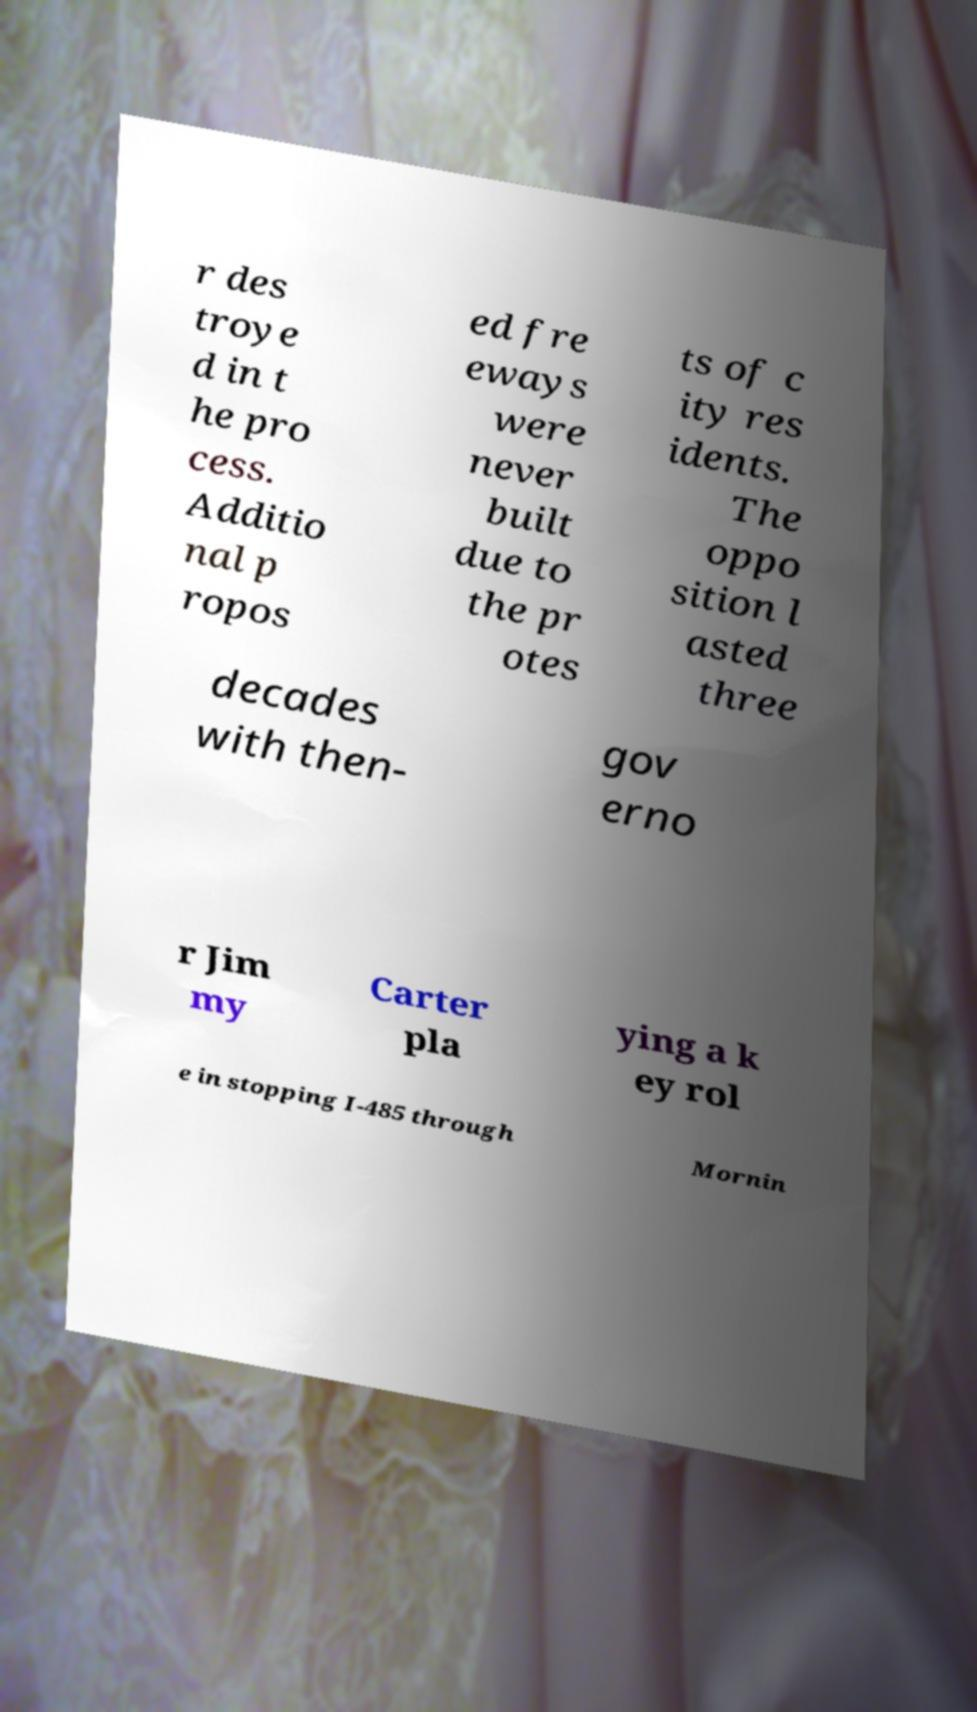I need the written content from this picture converted into text. Can you do that? r des troye d in t he pro cess. Additio nal p ropos ed fre eways were never built due to the pr otes ts of c ity res idents. The oppo sition l asted three decades with then- gov erno r Jim my Carter pla ying a k ey rol e in stopping I-485 through Mornin 